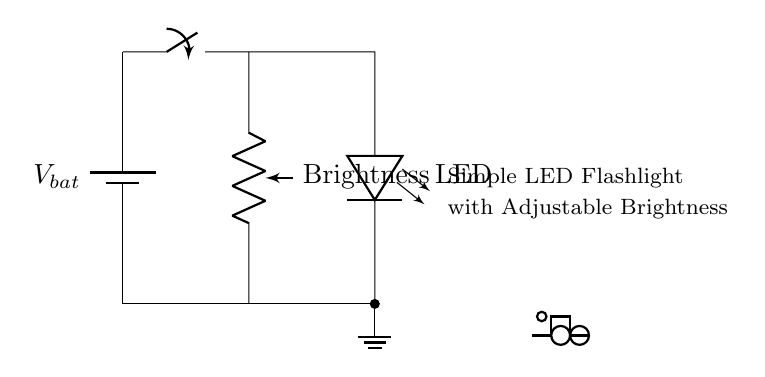What is the main purpose of this circuit? The main purpose of this circuit is to power an LED flashlight while allowing the user to adjust the brightness of the light produced. The components included (like the potentiometer) specifically facilitate this control.
Answer: LED flashlight What type of component is used for brightness control? The component used for brightness control in this circuit is a potentiometer, which allows varying resistance to adjust the brightness of the LED. It is labeled as "Brightness" in the diagram.
Answer: Potentiometer How many main components are in the circuit? The circuit consists of four main components: a battery, a switch, a potentiometer, and an LED. Counting each unique part gives a total of four main components in the circuit.
Answer: Four What does the switch do in this circuit? The switch in this circuit serves to open or close the connection, allowing the user to turn the flashlight on or off. When the switch is closed, the circuit is complete, and the LED lights up.
Answer: Turns the flashlight on/off If the brightness is decreased, what happens to the current in the LED? If the brightness is decreased by adjusting the potentiometer, the resistance in the circuit increases, causing the current flowing through the LED to decrease. This reduction in current results in a dimmer light output from the LED.
Answer: Current decreases What is the role of the battery in this circuit? The battery serves as the power source for the circuit, providing the necessary voltage to drive the current through the LED and the other components. Without the battery, there would be no power to operate the flashlight.
Answer: Power source 